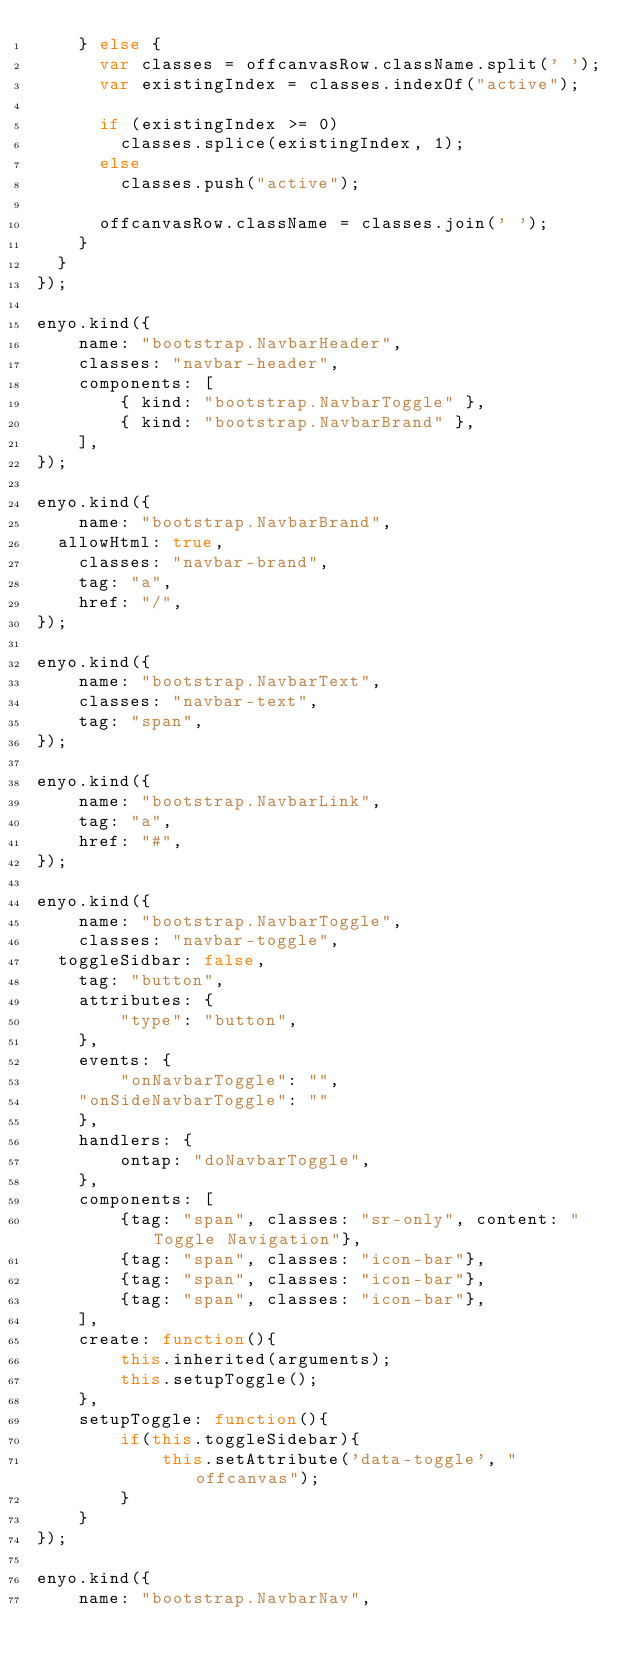Convert code to text. <code><loc_0><loc_0><loc_500><loc_500><_JavaScript_>    } else {
      var classes = offcanvasRow.className.split(' ');
      var existingIndex = classes.indexOf("active");

      if (existingIndex >= 0)
        classes.splice(existingIndex, 1);
      else
        classes.push("active");

      offcanvasRow.className = classes.join(' ');
    }
  }
});

enyo.kind({
	name: "bootstrap.NavbarHeader",
	classes: "navbar-header",
	components: [
		{ kind: "bootstrap.NavbarToggle" },
		{ kind: "bootstrap.NavbarBrand" },
	],
});

enyo.kind({
	name: "bootstrap.NavbarBrand",
  allowHtml: true,
	classes: "navbar-brand",
	tag: "a",
	href: "/",
});

enyo.kind({
	name: "bootstrap.NavbarText",
	classes: "navbar-text",
	tag: "span",
});

enyo.kind({
	name: "bootstrap.NavbarLink",
	tag: "a",
	href: "#",
});

enyo.kind({
	name: "bootstrap.NavbarToggle",
	classes: "navbar-toggle",
  toggleSidbar: false,
	tag: "button",  
	attributes: {
		"type": "button",
	},
	events: {
		"onNavbarToggle": "",
    "onSideNavbarToggle": ""
	},
	handlers: {
		ontap: "doNavbarToggle",
	},
	components: [
		{tag: "span", classes: "sr-only", content: "Toggle Navigation"},
		{tag: "span", classes: "icon-bar"},
		{tag: "span", classes: "icon-bar"},
		{tag: "span", classes: "icon-bar"},
	],
	create: function(){
		this.inherited(arguments);
		this.setupToggle();
	},
	setupToggle: function(){
		if(this.toggleSidebar){
			this.setAttribute('data-toggle', "offcanvas");
		}
	}
});

enyo.kind({
	name: "bootstrap.NavbarNav",</code> 